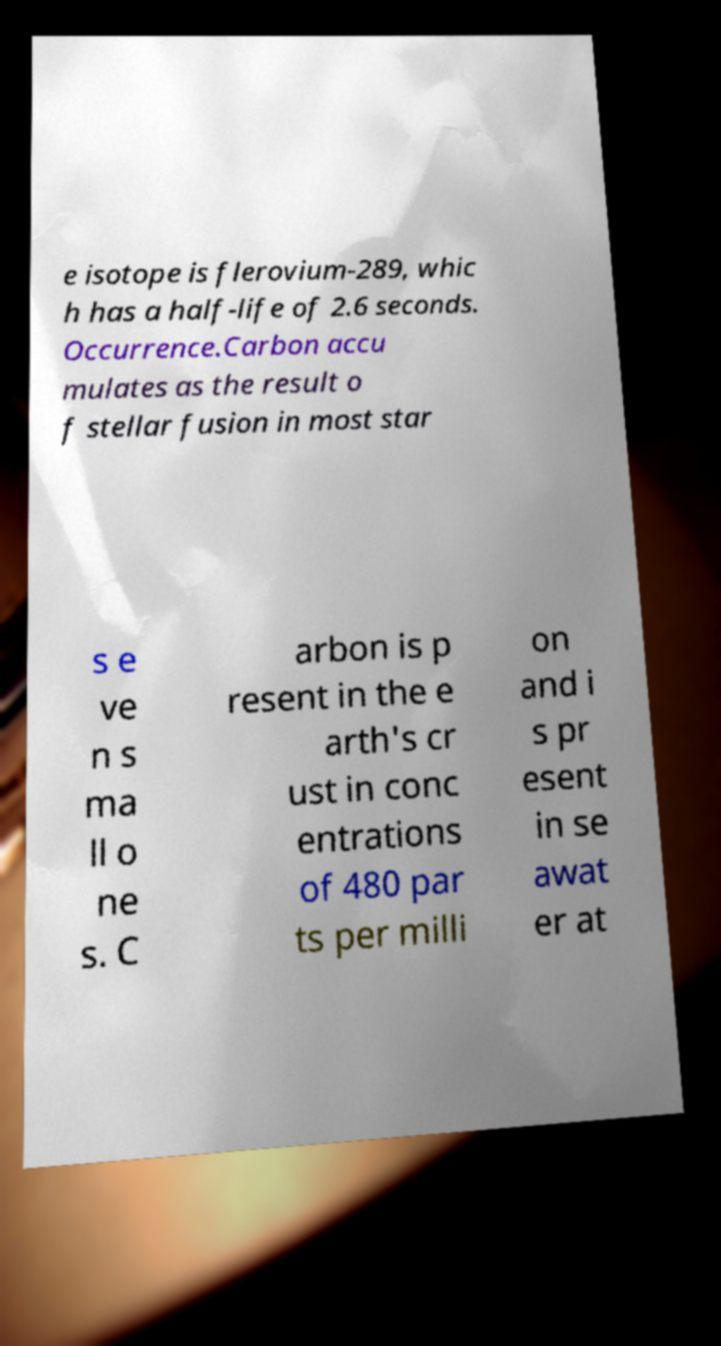There's text embedded in this image that I need extracted. Can you transcribe it verbatim? e isotope is flerovium-289, whic h has a half-life of 2.6 seconds. Occurrence.Carbon accu mulates as the result o f stellar fusion in most star s e ve n s ma ll o ne s. C arbon is p resent in the e arth's cr ust in conc entrations of 480 par ts per milli on and i s pr esent in se awat er at 